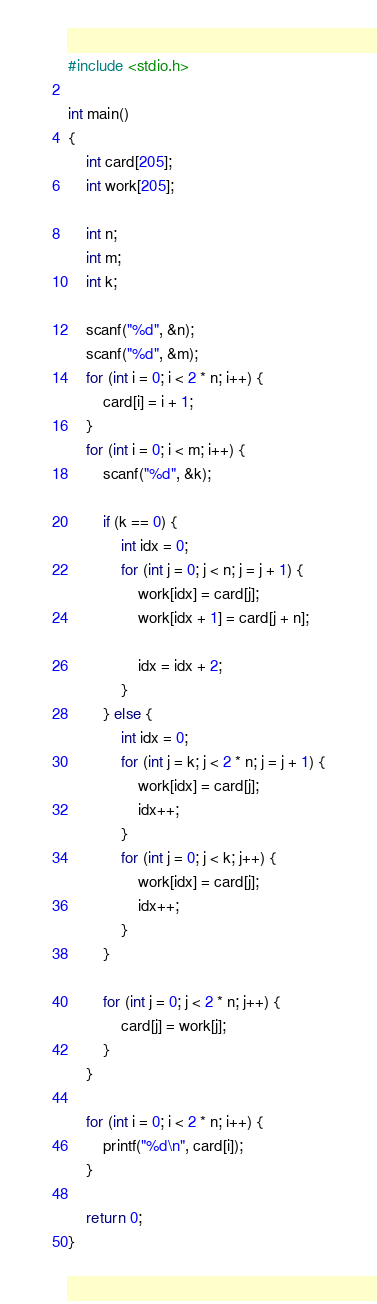Convert code to text. <code><loc_0><loc_0><loc_500><loc_500><_C_>#include <stdio.h>

int main()
{
    int card[205];
    int work[205];

    int n;
    int m;
    int k;

    scanf("%d", &n);
    scanf("%d", &m);
    for (int i = 0; i < 2 * n; i++) {
        card[i] = i + 1;
    }
    for (int i = 0; i < m; i++) {
        scanf("%d", &k);

        if (k == 0) {
            int idx = 0;
            for (int j = 0; j < n; j = j + 1) {
                work[idx] = card[j];
                work[idx + 1] = card[j + n];

                idx = idx + 2;
            }
        } else {
            int idx = 0;
            for (int j = k; j < 2 * n; j = j + 1) {
                work[idx] = card[j];
                idx++;
            }
            for (int j = 0; j < k; j++) {
                work[idx] = card[j];
                idx++;
            }
        }

        for (int j = 0; j < 2 * n; j++) {
            card[j] = work[j];
        }
    }

    for (int i = 0; i < 2 * n; i++) {
        printf("%d\n", card[i]);
    }

    return 0;
}

</code> 